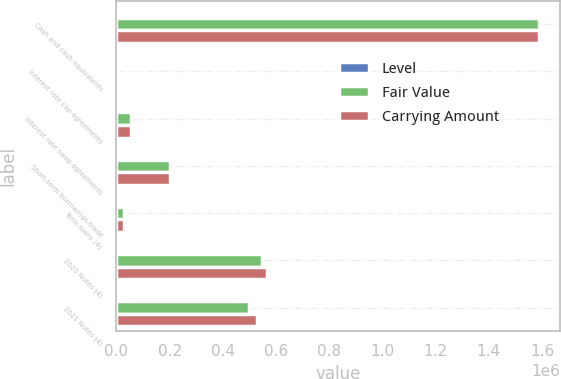<chart> <loc_0><loc_0><loc_500><loc_500><stacked_bar_chart><ecel><fcel>Cash and cash equivalents<fcel>Interest rate cap agreements<fcel>Interest rate swap agreements<fcel>Short-term borrowings-trade<fcel>Term loans (4)<fcel>2020 Notes (4)<fcel>2021 Notes (4)<nl><fcel>Level<fcel>1<fcel>2<fcel>2<fcel>1<fcel>2<fcel>1<fcel>1<nl><fcel>Fair Value<fcel>1.58699e+06<fcel>4232<fcel>53824<fcel>199771<fcel>29191<fcel>545701<fcel>496859<nl><fcel>Carrying Amount<fcel>1.58699e+06<fcel>4232<fcel>53824<fcel>199771<fcel>29191<fcel>566500<fcel>530000<nl></chart> 